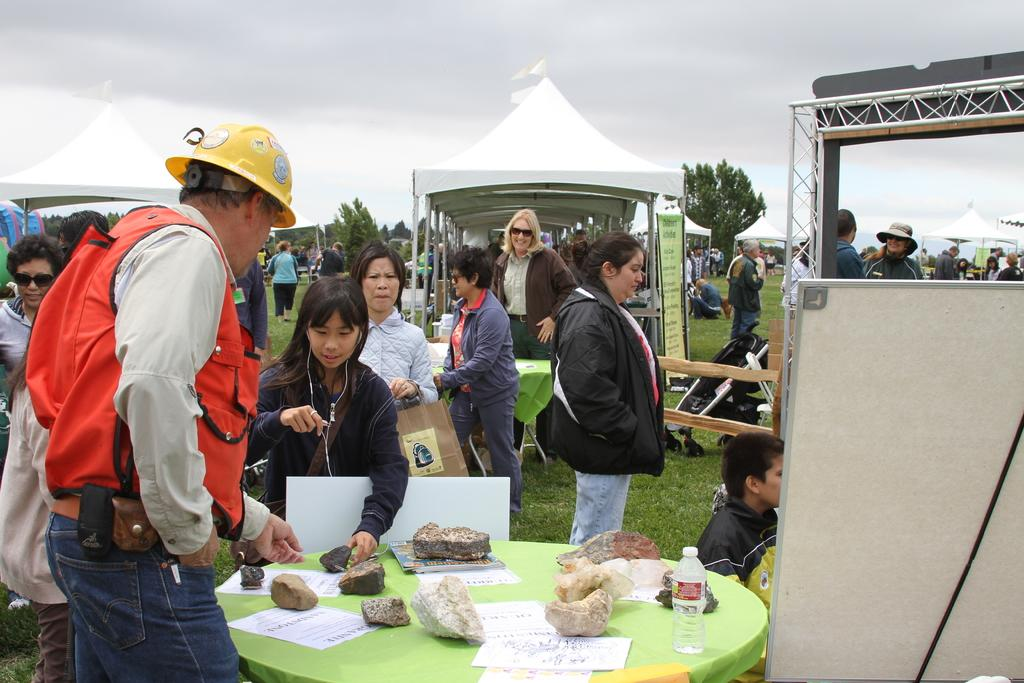What can be seen in the image involving people? There are people standing in the image. What objects are on the table in the image? There are stones, papers, and a water bottle on the table in the image. What is visible in the background of the image? There are trees visible around the area in the image. What flavor of house is depicted in the image? There is no house present in the image, and therefore no flavor can be associated with it. What is the position of the elbow of the person standing in the image? The position of the elbow of the person standing in the image cannot be determined from the provided facts. 